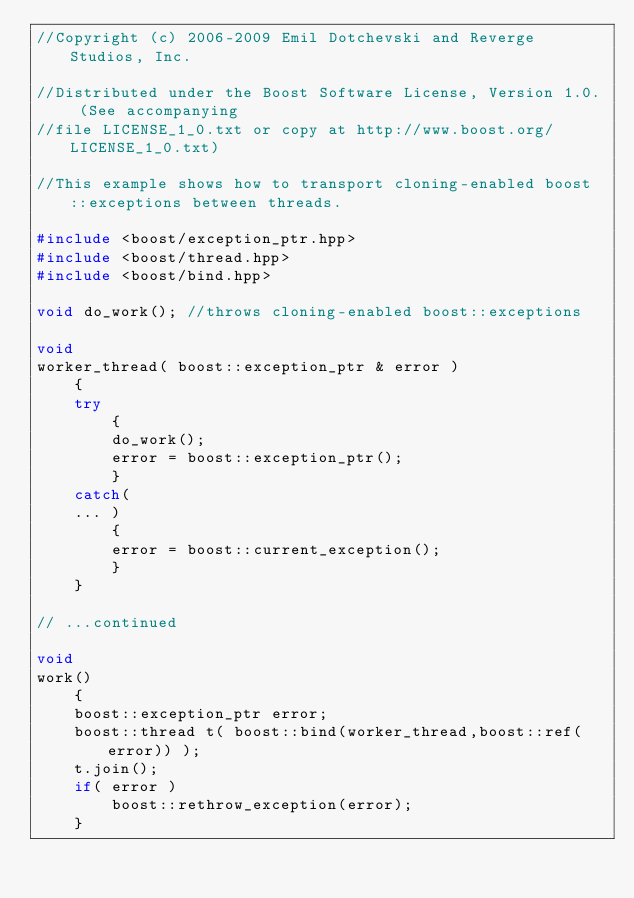Convert code to text. <code><loc_0><loc_0><loc_500><loc_500><_C++_>//Copyright (c) 2006-2009 Emil Dotchevski and Reverge Studios, Inc.

//Distributed under the Boost Software License, Version 1.0. (See accompanying
//file LICENSE_1_0.txt or copy at http://www.boost.org/LICENSE_1_0.txt)

//This example shows how to transport cloning-enabled boost::exceptions between threads.

#include <boost/exception_ptr.hpp>
#include <boost/thread.hpp>
#include <boost/bind.hpp>

void do_work(); //throws cloning-enabled boost::exceptions

void
worker_thread( boost::exception_ptr & error )
    {
    try
        {
        do_work();
        error = boost::exception_ptr();
        }
    catch(
    ... )
        {
        error = boost::current_exception();
        }
    }

// ...continued

void
work()
    {
    boost::exception_ptr error;
    boost::thread t( boost::bind(worker_thread,boost::ref(error)) );
    t.join();
    if( error )
        boost::rethrow_exception(error);
    }
</code> 